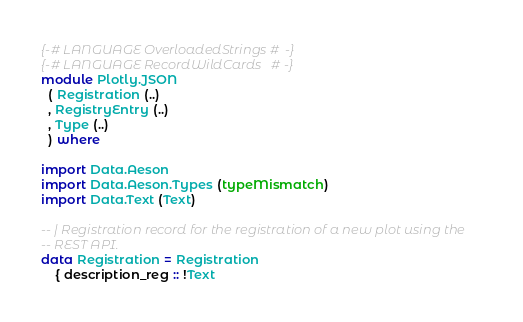Convert code to text. <code><loc_0><loc_0><loc_500><loc_500><_Haskell_>{-# LANGUAGE OverloadedStrings #-}
{-# LANGUAGE RecordWildCards   #-}
module Plotly.JSON
  ( Registration (..)
  , RegistryEntry (..)
  , Type (..)
  ) where

import Data.Aeson
import Data.Aeson.Types (typeMismatch)
import Data.Text (Text)

-- | Registration record for the registration of a new plot using the
-- REST API.
data Registration = Registration
    { description_reg :: !Text</code> 